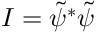Convert formula to latex. <formula><loc_0><loc_0><loc_500><loc_500>I = \tilde { \psi } ^ { * } \tilde { \psi }</formula> 